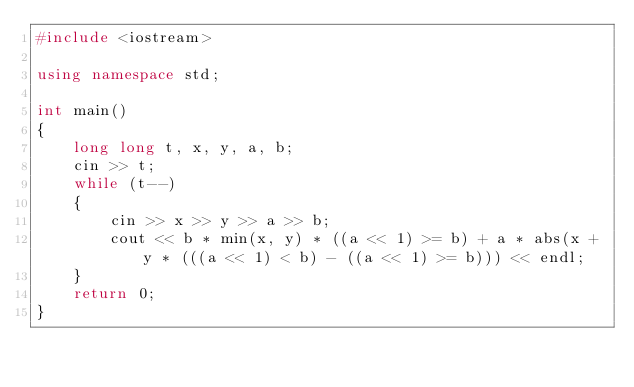<code> <loc_0><loc_0><loc_500><loc_500><_C++_>#include <iostream>

using namespace std;

int main()
{
    long long t, x, y, a, b;
    cin >> t;
    while (t--)
    {
        cin >> x >> y >> a >> b;
        cout << b * min(x, y) * ((a << 1) >= b) + a * abs(x + y * (((a << 1) < b) - ((a << 1) >= b))) << endl;
    }
    return 0;
}
</code> 